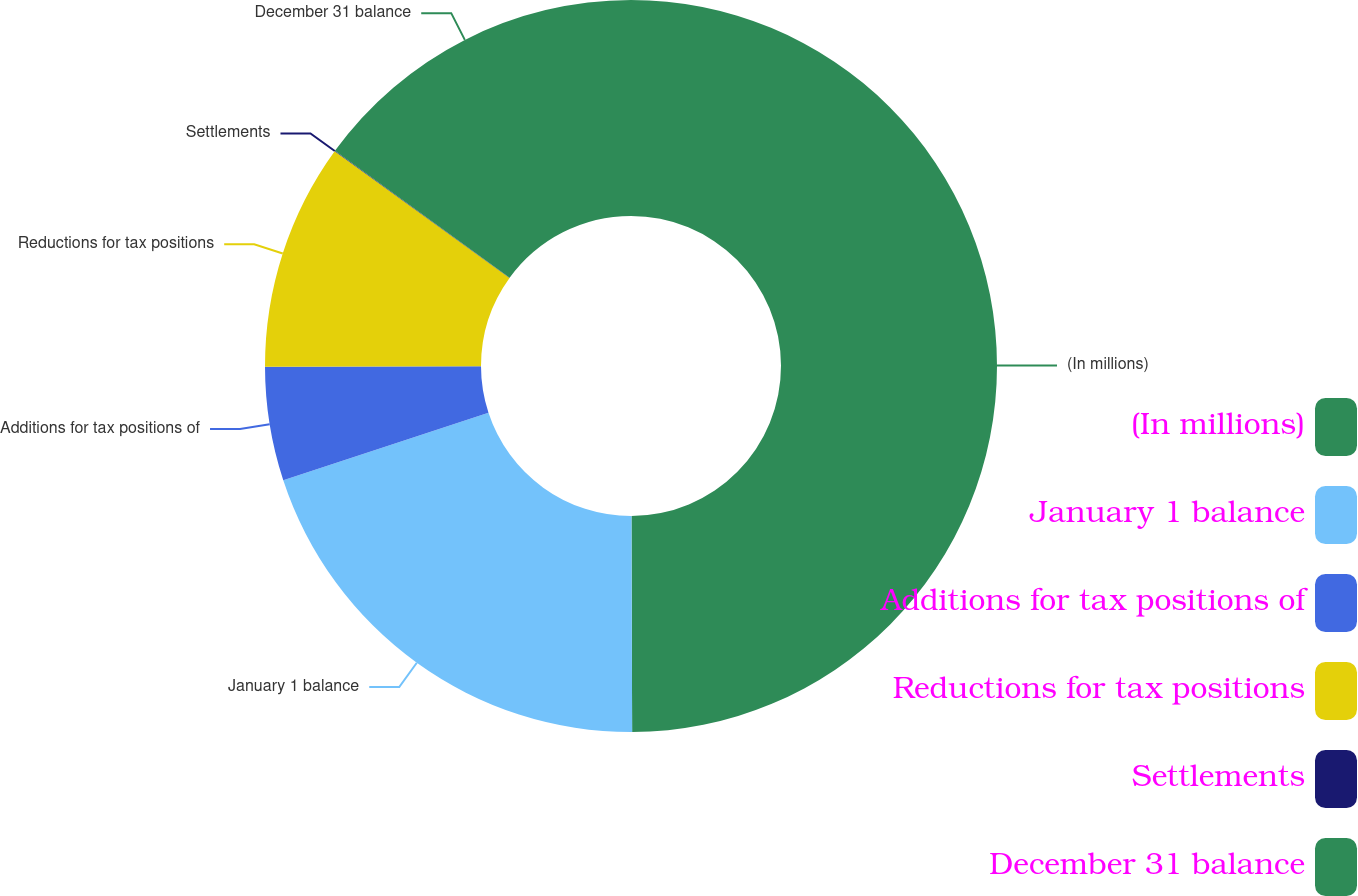Convert chart to OTSL. <chart><loc_0><loc_0><loc_500><loc_500><pie_chart><fcel>(In millions)<fcel>January 1 balance<fcel>Additions for tax positions of<fcel>Reductions for tax positions<fcel>Settlements<fcel>December 31 balance<nl><fcel>49.95%<fcel>20.0%<fcel>5.02%<fcel>10.01%<fcel>0.02%<fcel>15.0%<nl></chart> 